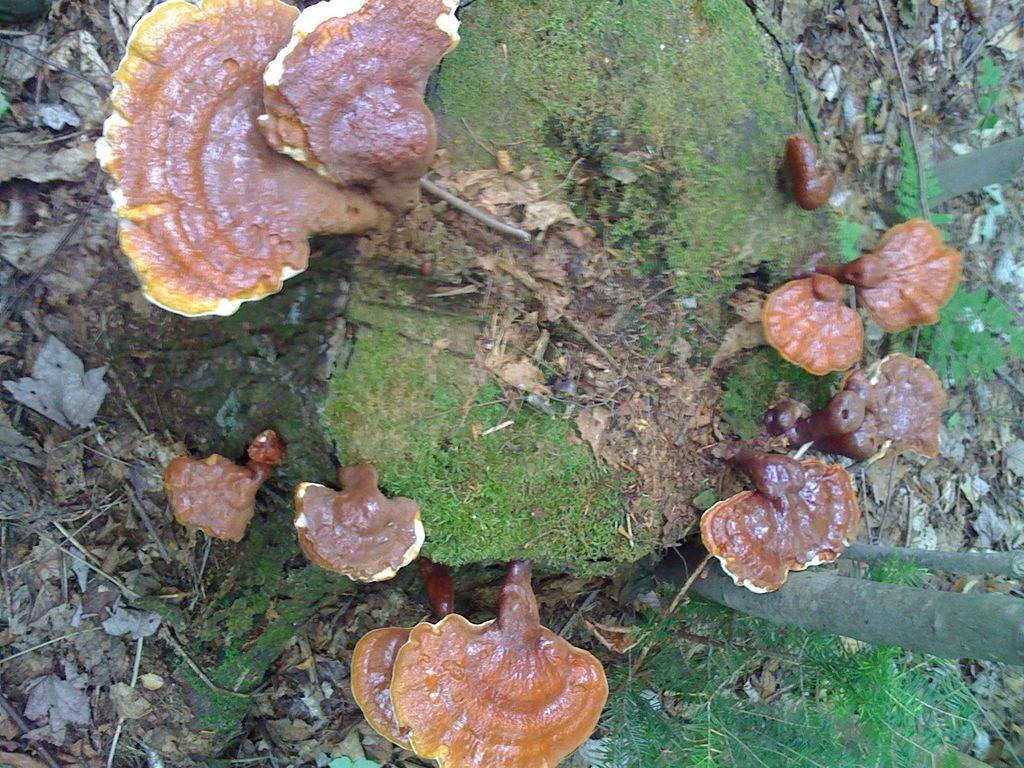What type of vegetation can be seen on the ground in the image? There are mushrooms on the ground in the image. What type of vegetation surrounds the mushrooms in the image? There is grass surrounding the mushrooms in the image. What scent can be detected from the mushrooms in the image? The image does not provide any information about the scent of the mushrooms, so it cannot be determined from the image. 